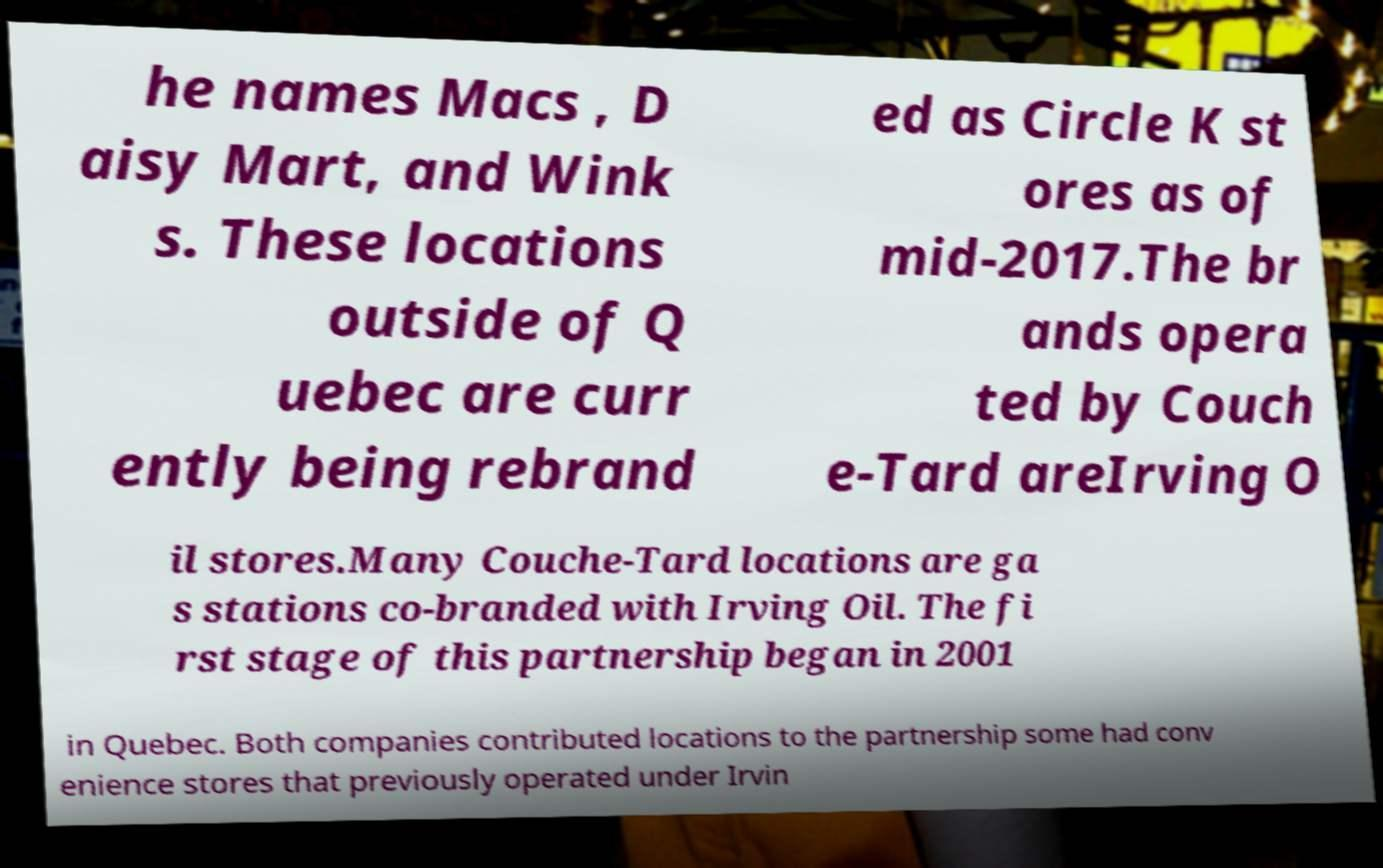There's text embedded in this image that I need extracted. Can you transcribe it verbatim? he names Macs , D aisy Mart, and Wink s. These locations outside of Q uebec are curr ently being rebrand ed as Circle K st ores as of mid-2017.The br ands opera ted by Couch e-Tard areIrving O il stores.Many Couche-Tard locations are ga s stations co-branded with Irving Oil. The fi rst stage of this partnership began in 2001 in Quebec. Both companies contributed locations to the partnership some had conv enience stores that previously operated under Irvin 